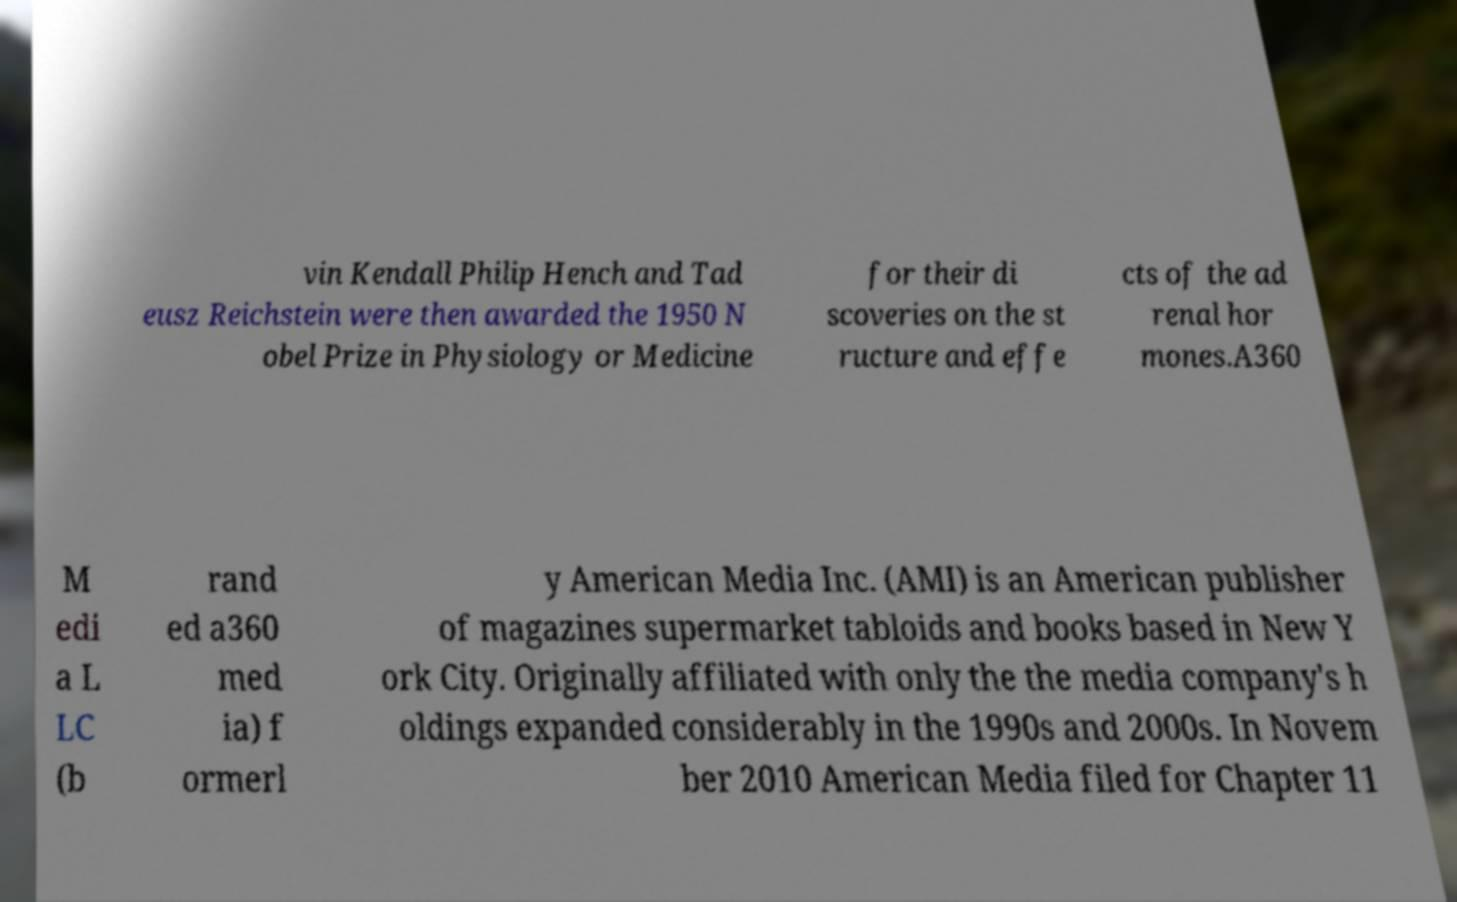What messages or text are displayed in this image? I need them in a readable, typed format. vin Kendall Philip Hench and Tad eusz Reichstein were then awarded the 1950 N obel Prize in Physiology or Medicine for their di scoveries on the st ructure and effe cts of the ad renal hor mones.A360 M edi a L LC (b rand ed a360 med ia) f ormerl y American Media Inc. (AMI) is an American publisher of magazines supermarket tabloids and books based in New Y ork City. Originally affiliated with only the the media company's h oldings expanded considerably in the 1990s and 2000s. In Novem ber 2010 American Media filed for Chapter 11 